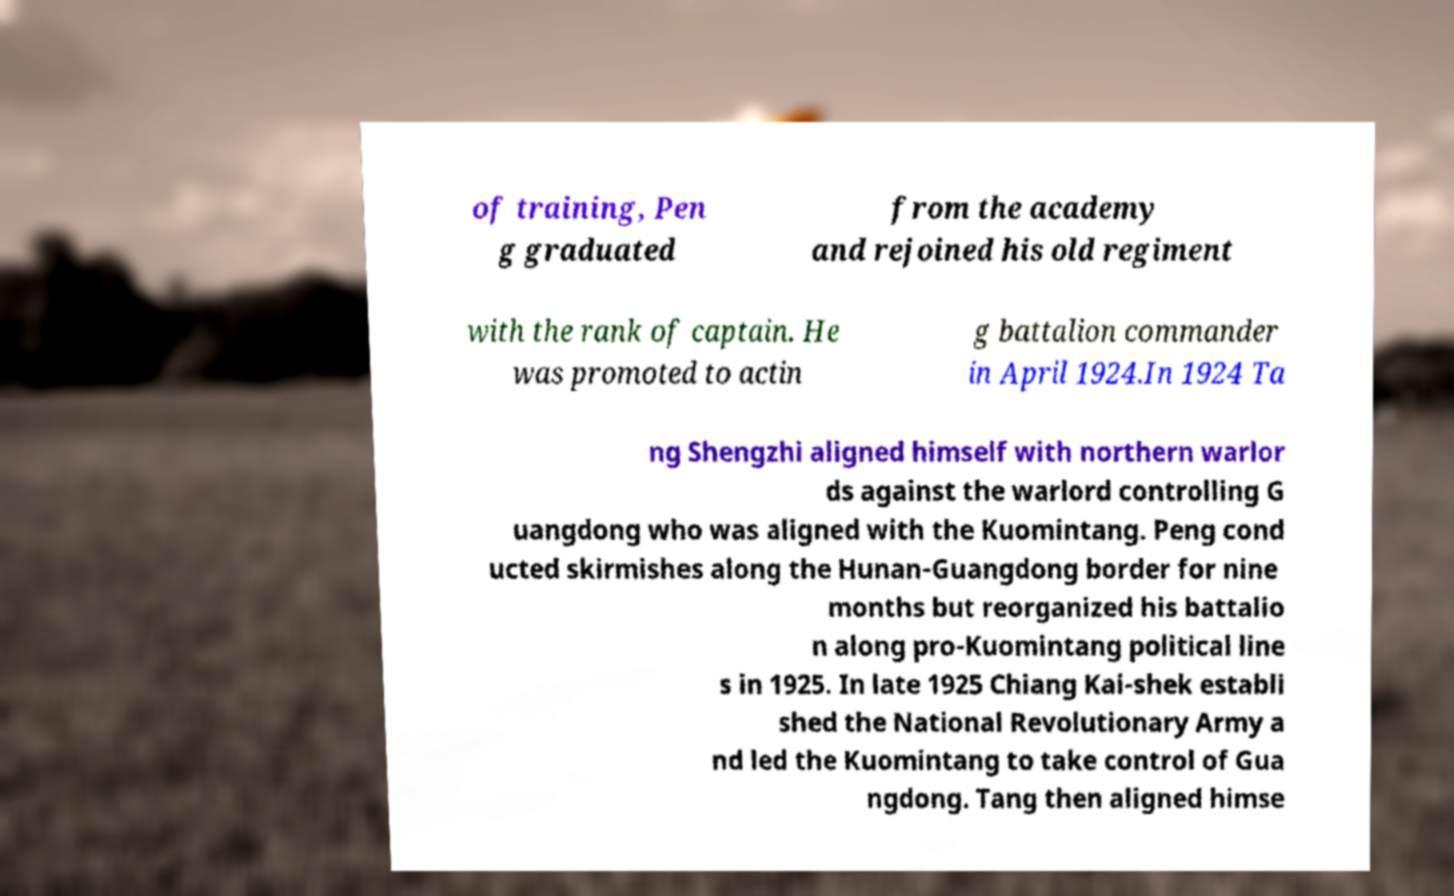Could you extract and type out the text from this image? of training, Pen g graduated from the academy and rejoined his old regiment with the rank of captain. He was promoted to actin g battalion commander in April 1924.In 1924 Ta ng Shengzhi aligned himself with northern warlor ds against the warlord controlling G uangdong who was aligned with the Kuomintang. Peng cond ucted skirmishes along the Hunan-Guangdong border for nine months but reorganized his battalio n along pro-Kuomintang political line s in 1925. In late 1925 Chiang Kai-shek establi shed the National Revolutionary Army a nd led the Kuomintang to take control of Gua ngdong. Tang then aligned himse 